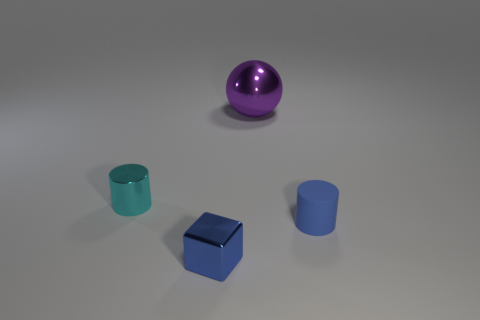Add 1 tiny yellow cubes. How many objects exist? 5 Subtract all blocks. How many objects are left? 3 Add 3 blue things. How many blue things exist? 5 Subtract 0 green cylinders. How many objects are left? 4 Subtract all small blue blocks. Subtract all green shiny balls. How many objects are left? 3 Add 2 cylinders. How many cylinders are left? 4 